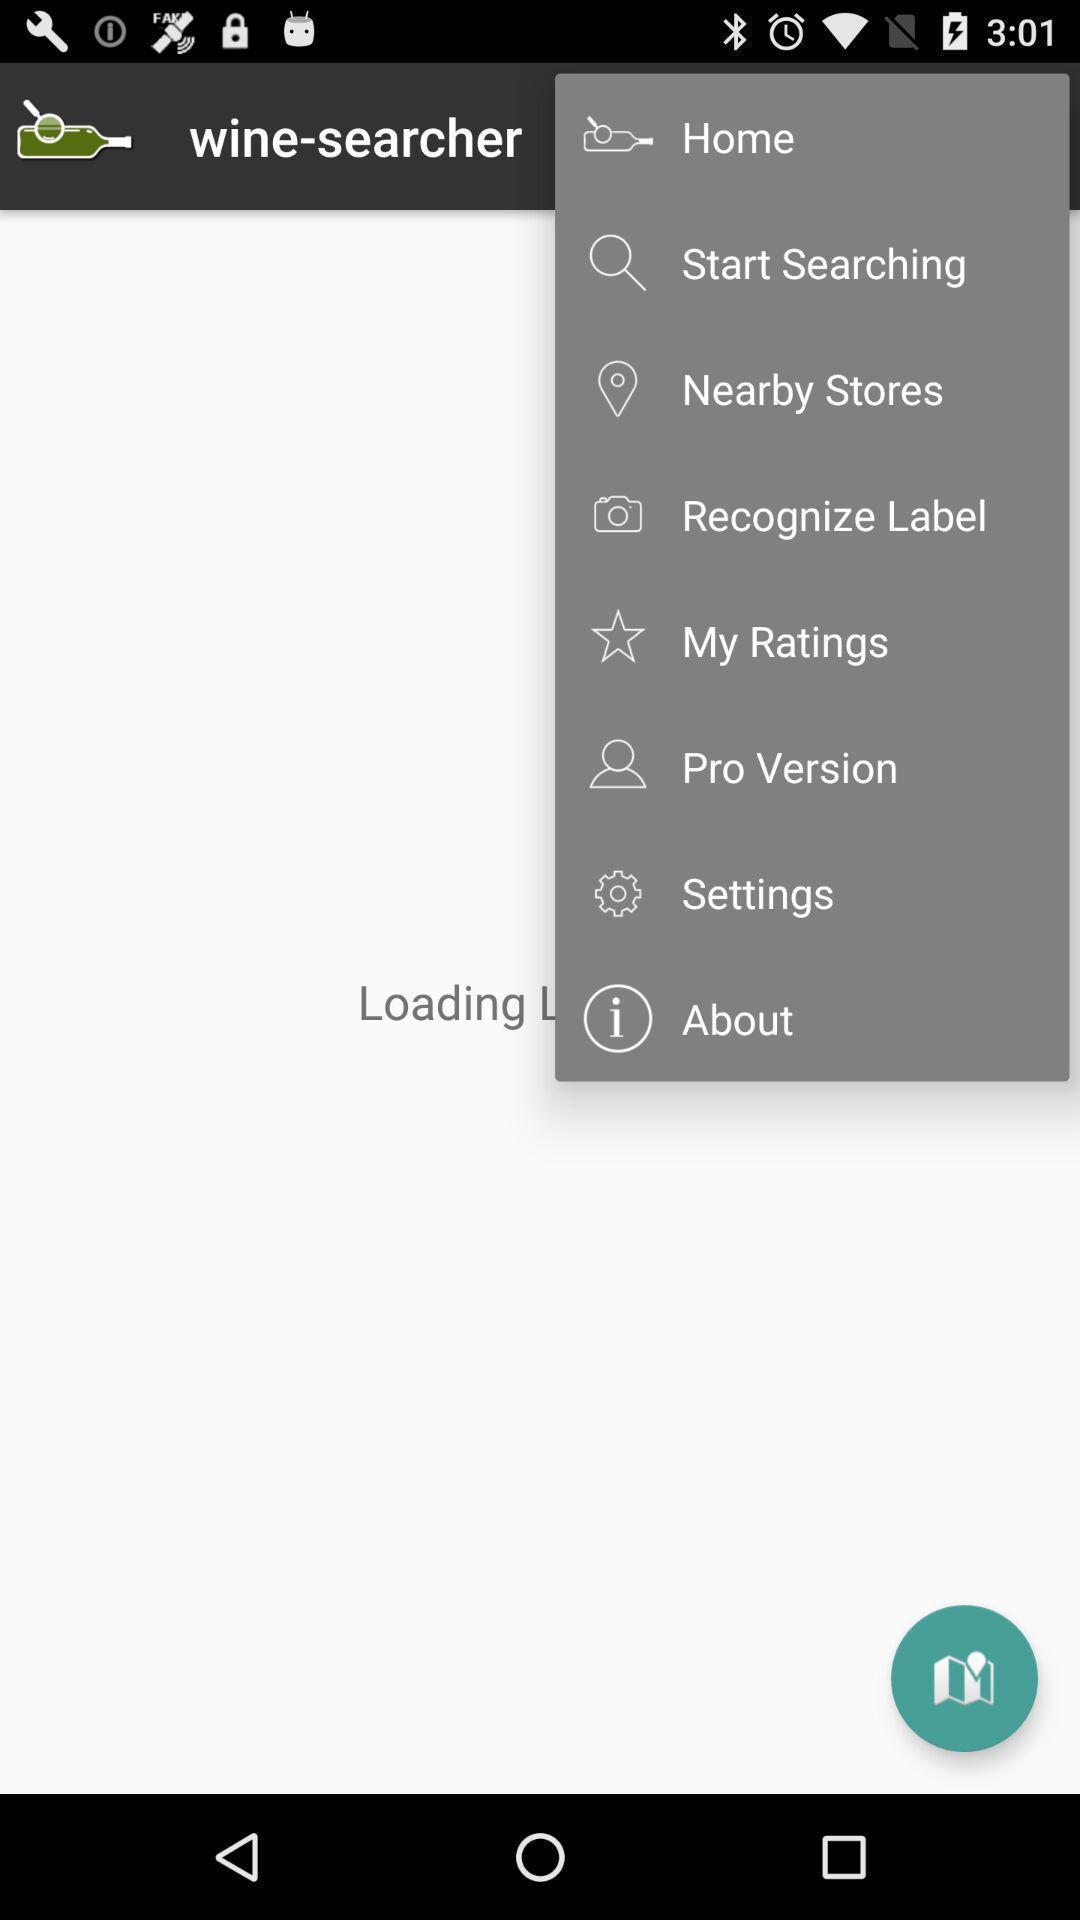Describe the content in this image. Pull down menu of various options. 